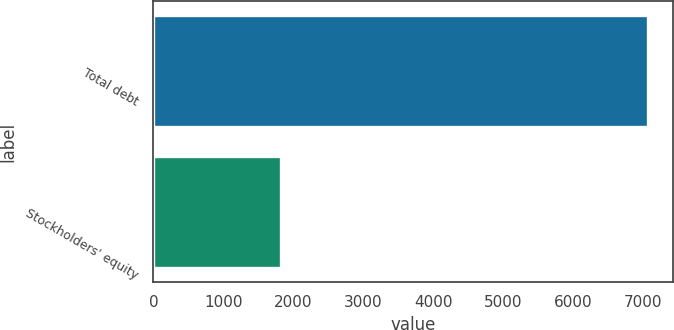Convert chart to OTSL. <chart><loc_0><loc_0><loc_500><loc_500><bar_chart><fcel>Total debt<fcel>Stockholders' equity<nl><fcel>7078<fcel>1828<nl></chart> 